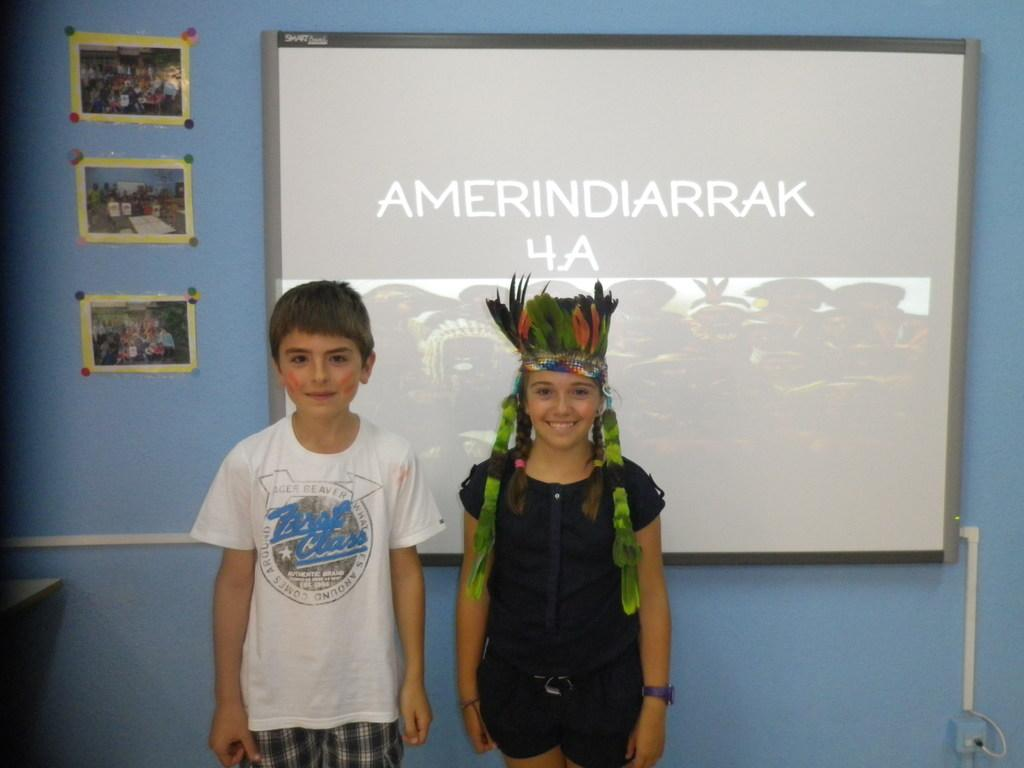How many kids are in the image? There are two kids standing at the bottom of the image. What is the facial expression of the kids? The kids are smiling. What is located behind the kids? There is a board behind the kids. What can be seen on the wall in the background? There are posters on a wall in the background. What type of gun is the tramp holding in the image? There is no tramp or gun present in the image. What book are the kids reading in the image? There is no book or reading activity depicted in the image. 